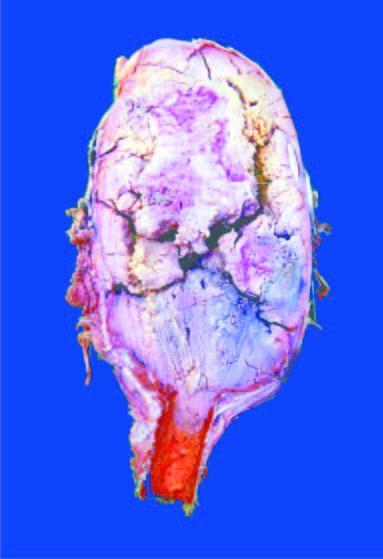does sectioned surface show circumscribed, dark tan, haemorrhagic and necrotic tumour?
Answer the question using a single word or phrase. Yes 